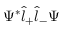Convert formula to latex. <formula><loc_0><loc_0><loc_500><loc_500>\Psi ^ { * } \hat { l } _ { + } \hat { l } _ { - } \Psi</formula> 